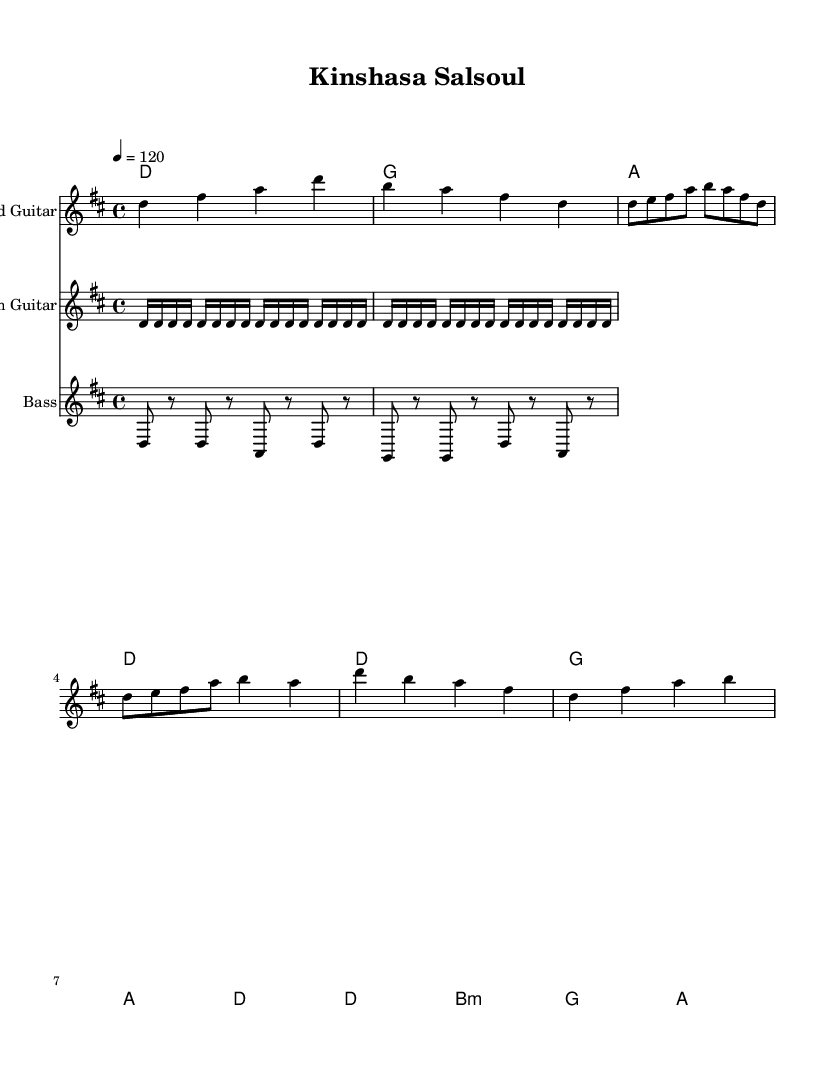What is the key signature of this music? The key signature has two sharps (F# and C#), indicating that it is in the key of D major.
Answer: D major What is the time signature of this music? The time signature appears at the beginning of the score and shows a four over four structure, which indicates there are four beats in each measure.
Answer: 4/4 What is the tempo marking for this piece? The tempo marking is indicated by the text "4 = 120", which suggests that the quarter note should be played at a speed of 120 beats per minute.
Answer: 120 How many measures are in the intro section? Counting the measures in the intro, we find that there are four distinct measures used for the introduction of the piece.
Answer: 4 Which instrument plays the syncopated bassline? The notation is labeled for the staff, and the bass guitar is responsible for the syncopated rhythm shown in the measures.
Answer: Bass What chord follows the D major chord in the verses? By analyzing the chord progression in the verse section, the D major chord is followed by a G major chord in the sequence.
Answer: G What unique rhythm pattern is used for the rhythm guitar? The rhythm guitar part is characterized by a repeated soukous pattern, specifically indicated as a continuous sequence of sixteenth notes in the notation.
Answer: Soukous pattern 